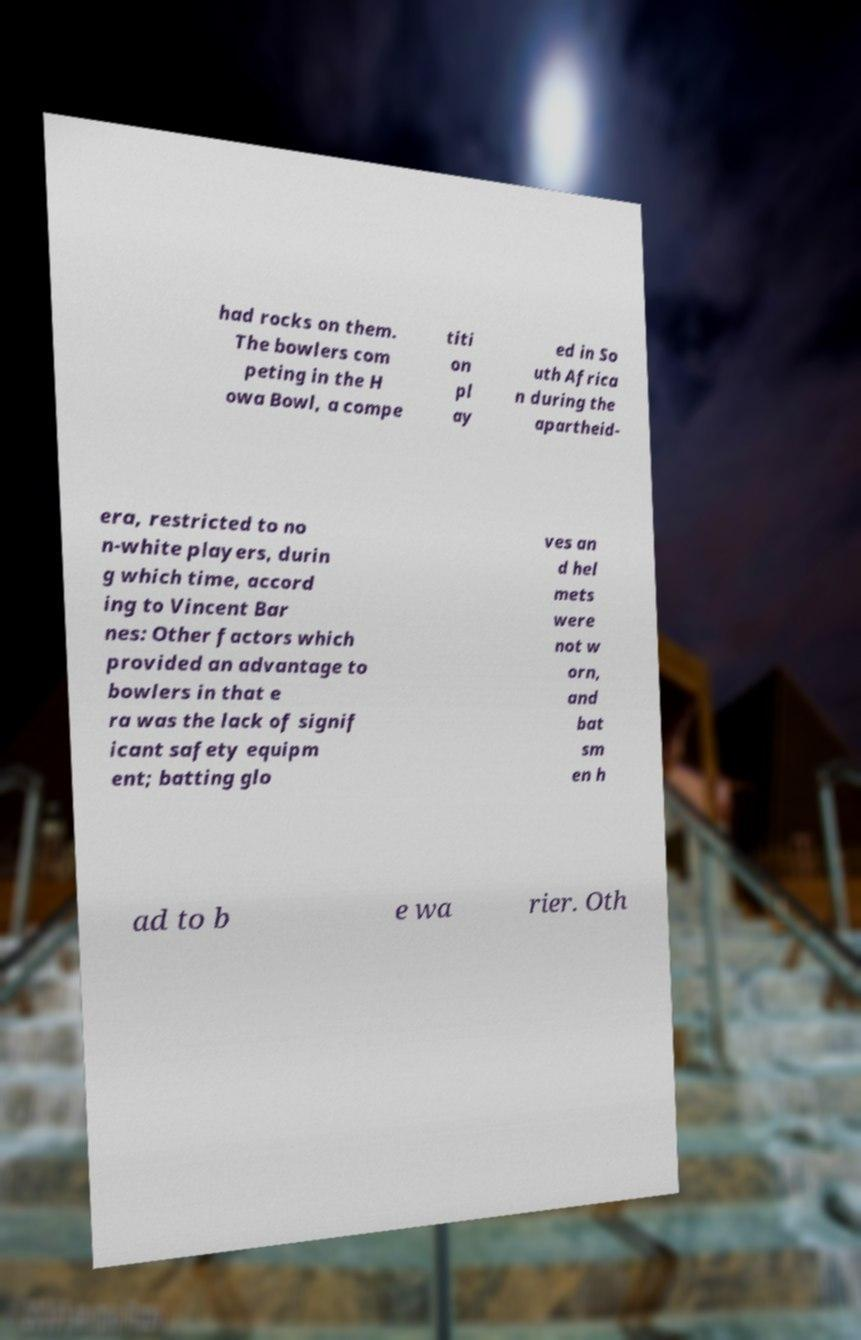Can you accurately transcribe the text from the provided image for me? had rocks on them. The bowlers com peting in the H owa Bowl, a compe titi on pl ay ed in So uth Africa n during the apartheid- era, restricted to no n-white players, durin g which time, accord ing to Vincent Bar nes: Other factors which provided an advantage to bowlers in that e ra was the lack of signif icant safety equipm ent; batting glo ves an d hel mets were not w orn, and bat sm en h ad to b e wa rier. Oth 